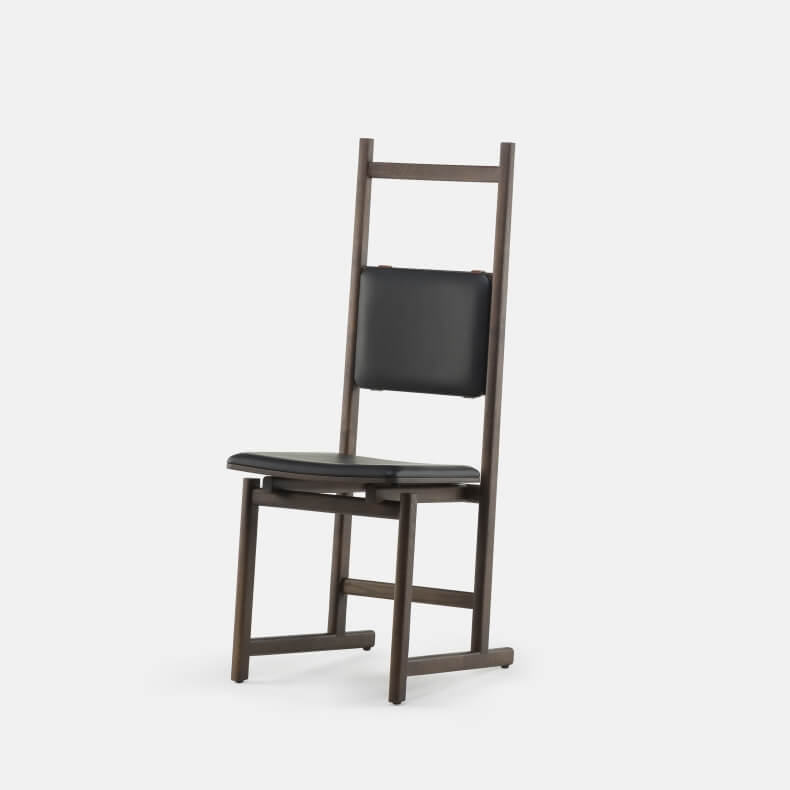What kind of room lighting would best complement this chair's features? The chair would be best complemented by modern and minimalist lighting solutions. Overhead pendant lights or track lighting with a sleek, streamlined design would highlight the chair's silhouettes and materials elegantly. Warm, white lights or adjustable LED lighting can bring out the richness of the dark frame and the sleekness of the black upholstery. Additionally, strategically placed floor lamps or table lamps with simple, clean lines can create a cozy ambiance that enhances the chair's design. Light fixtures with metallic or black finishes would blend harmoniously with the chair, maintaining cohesiveness in the overall decor. For a short response: Do you think this chair could fit well in a café setting? Yes, the chair could suit a modern, minimalist café, adding a sleek and sophisticated touch to the seating arrangement. Describe a fantasy-themed café where this chair would be a central piece. In a fantasy-themed café, this chair could be central in 'The Enchanted Study,' a section that replicates an ancient library where mythical creatures once gathered for secretive meetings. With bookshelves filled with ancient scrolls and potions, magical artifacts displayed in glass cases, and an ethereal glow emanating from floating lanterns, this chair would serve as a 'wise seat.' Patrons sitting on the chair would be able to ask for wisdom, as it would be rumored that the chair retains the knowledge of old council members who once sat upon it. Intricately woven fabric in deep purples and blues would adorn the cushion, adding an air of mystique and enchantment to the atmosphere, making each experience seated here feel like stepping into a storybook. 